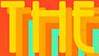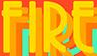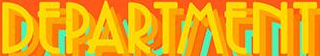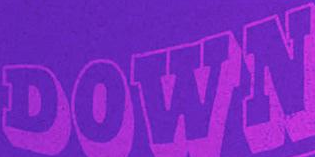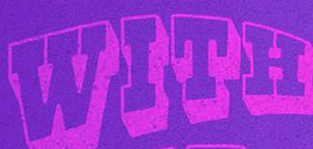What text is displayed in these images sequentially, separated by a semicolon? THE; FIRE; DEPARTMENT; DOWN; WITH 